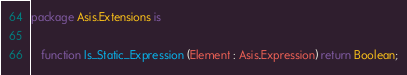<code> <loc_0><loc_0><loc_500><loc_500><_Ada_>package Asis.Extensions is

   function Is_Static_Expression (Element : Asis.Expression) return Boolean;</code> 